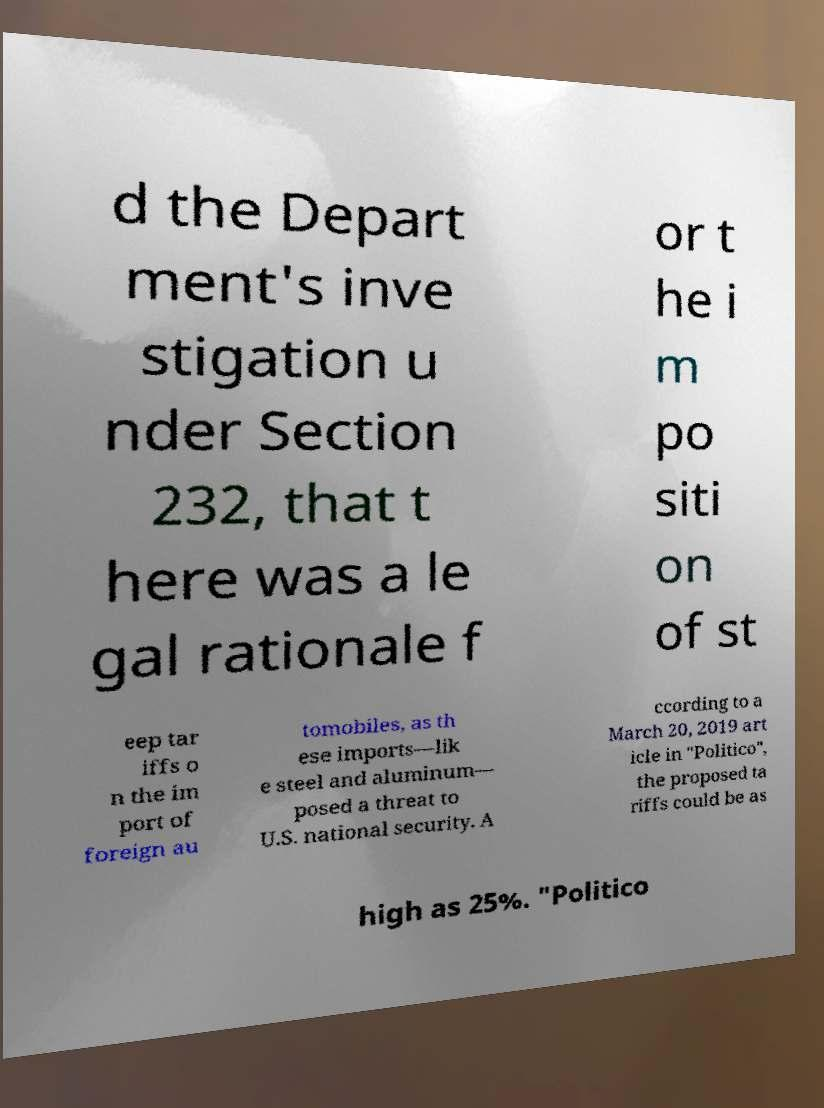Can you accurately transcribe the text from the provided image for me? d the Depart ment's inve stigation u nder Section 232, that t here was a le gal rationale f or t he i m po siti on of st eep tar iffs o n the im port of foreign au tomobiles, as th ese imports—lik e steel and aluminum— posed a threat to U.S. national security. A ccording to a March 20, 2019 art icle in "Politico", the proposed ta riffs could be as high as 25%. "Politico 